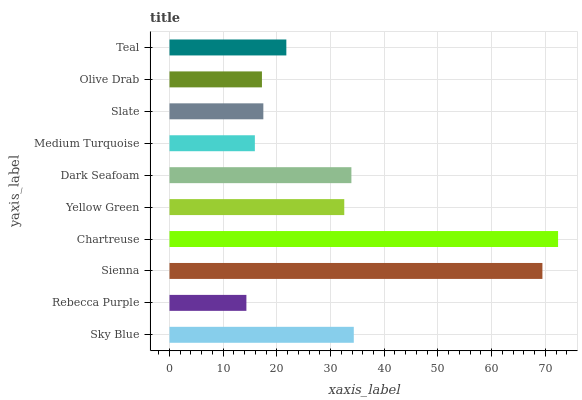Is Rebecca Purple the minimum?
Answer yes or no. Yes. Is Chartreuse the maximum?
Answer yes or no. Yes. Is Sienna the minimum?
Answer yes or no. No. Is Sienna the maximum?
Answer yes or no. No. Is Sienna greater than Rebecca Purple?
Answer yes or no. Yes. Is Rebecca Purple less than Sienna?
Answer yes or no. Yes. Is Rebecca Purple greater than Sienna?
Answer yes or no. No. Is Sienna less than Rebecca Purple?
Answer yes or no. No. Is Yellow Green the high median?
Answer yes or no. Yes. Is Teal the low median?
Answer yes or no. Yes. Is Rebecca Purple the high median?
Answer yes or no. No. Is Medium Turquoise the low median?
Answer yes or no. No. 